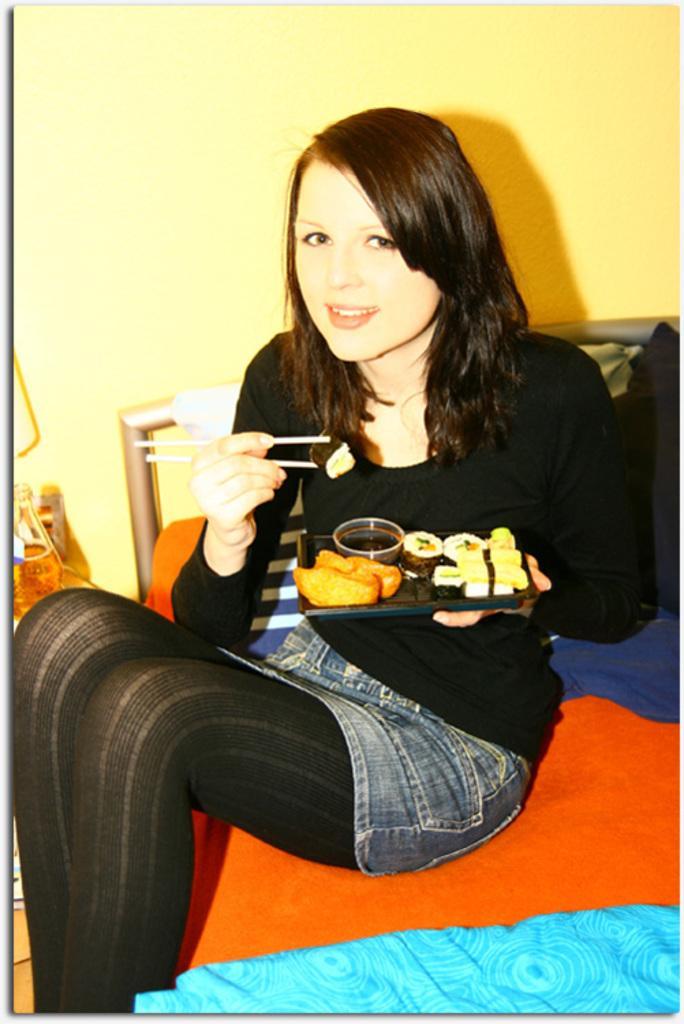How would you summarize this image in a sentence or two? In this image we can see there is a person sitting on the bed and holding a plate. On the plate there are some food items and in the other hand there are sticks. At the side there is a bottle and at the back there is a wall. 